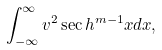<formula> <loc_0><loc_0><loc_500><loc_500>\int _ { - \infty } ^ { \infty } v ^ { 2 } \sec h ^ { m - 1 } { x } d x ,</formula> 